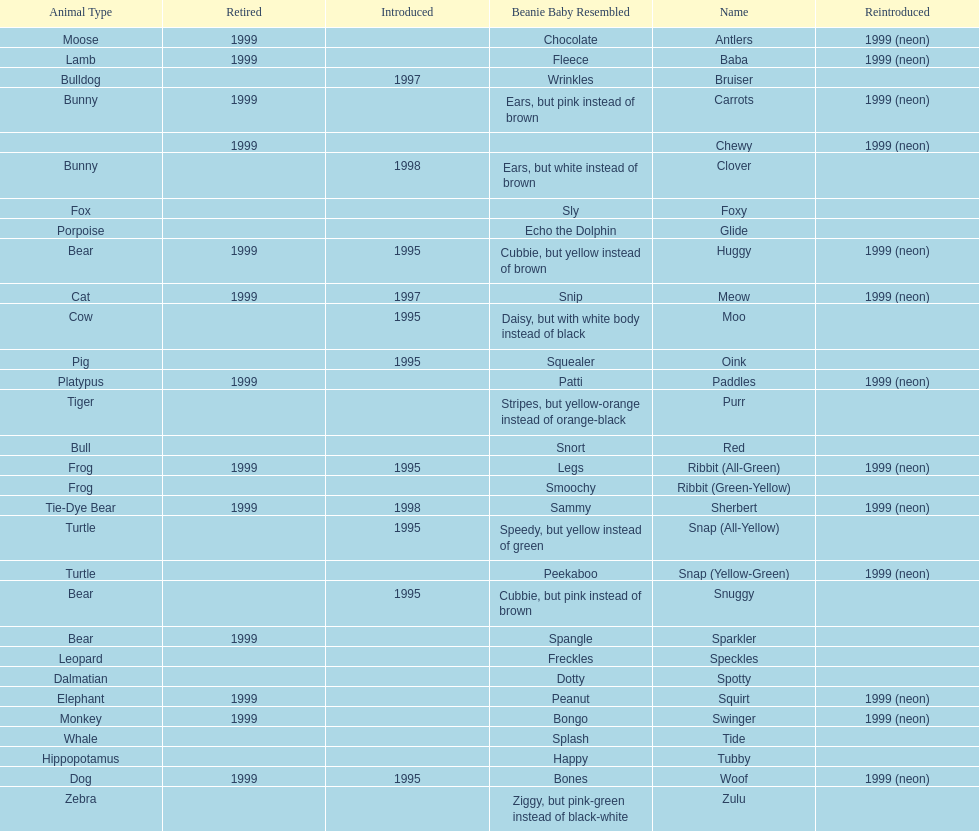How long was woof the dog sold before it was retired? 4 years. 